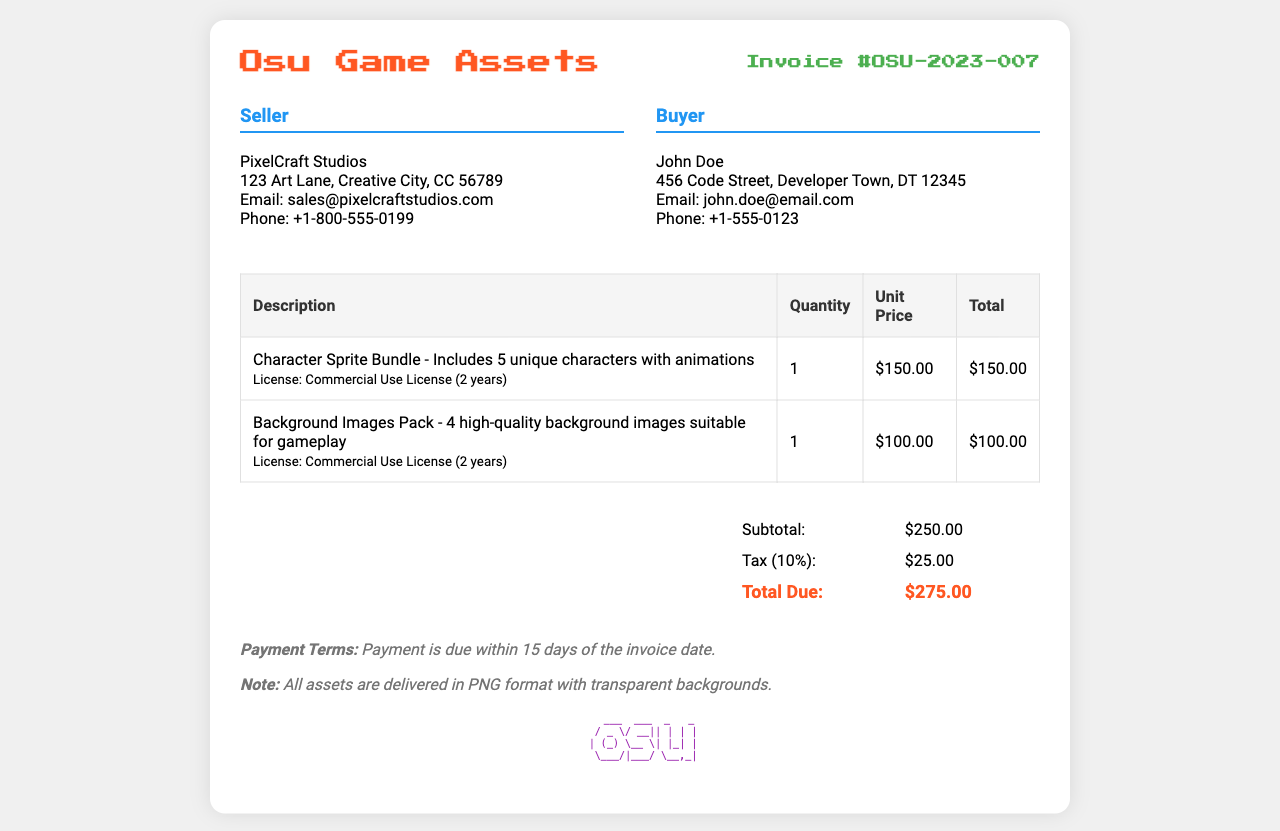What is the invoice number? The invoice number is listed at the top of the document under the title.
Answer: OSU-2023-007 Who is the seller? The seller's name is clearly stated in the seller details section.
Answer: PixelCraft Studios What is the total amount due? The total due is found in the summary table at the bottom of the invoice.
Answer: $275.00 What is the license duration for the assets? The license duration is mentioned in the description of each asset in the invoice table.
Answer: 2 years How many character sprites are included in the bundle? The document specifies the number of unique characters included in the character sprite bundle.
Answer: 5 What is the unit price of the Background Images Pack? The unit price is listed in the invoice table next to the corresponding item.
Answer: $100.00 What are the payment terms stated in the invoice? The payment terms are located in the additional notes section of the invoice.
Answer: Payment is due within 15 days of the invoice date What is the subtotal amount before tax? The subtotal is presented in the summary table of the document.
Answer: $250.00 What type of assets are detailed in this invoice? The types of assets are described in the invoice table, specifying the nature of the items purchased.
Answer: Character sprites and background images 